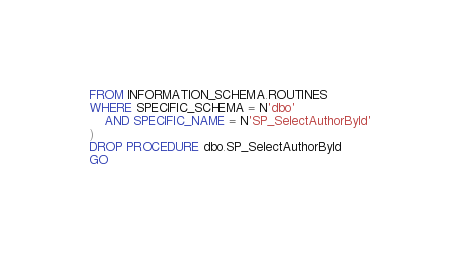<code> <loc_0><loc_0><loc_500><loc_500><_SQL_>FROM INFORMATION_SCHEMA.ROUTINES
WHERE SPECIFIC_SCHEMA = N'dbo'
    AND SPECIFIC_NAME = N'SP_SelectAuthorById'
)
DROP PROCEDURE dbo.SP_SelectAuthorById
GO</code> 